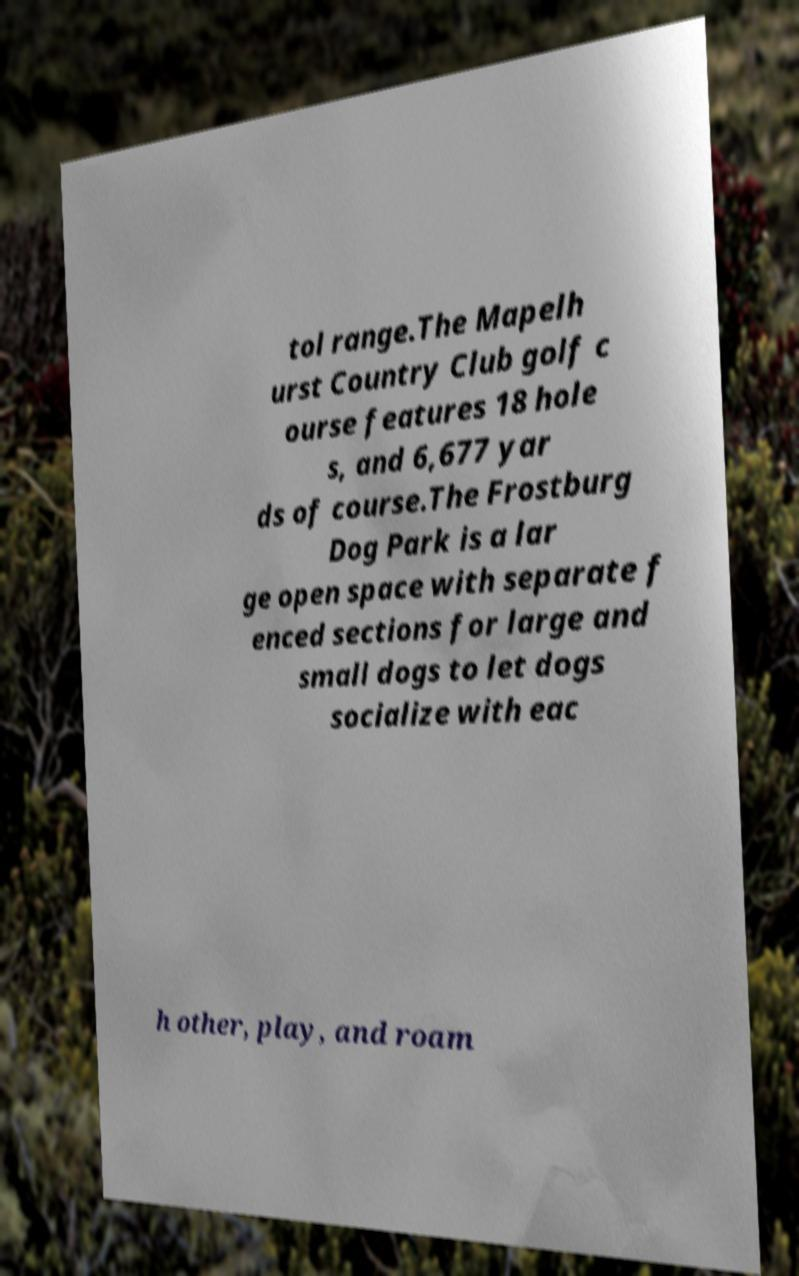Could you extract and type out the text from this image? tol range.The Mapelh urst Country Club golf c ourse features 18 hole s, and 6,677 yar ds of course.The Frostburg Dog Park is a lar ge open space with separate f enced sections for large and small dogs to let dogs socialize with eac h other, play, and roam 